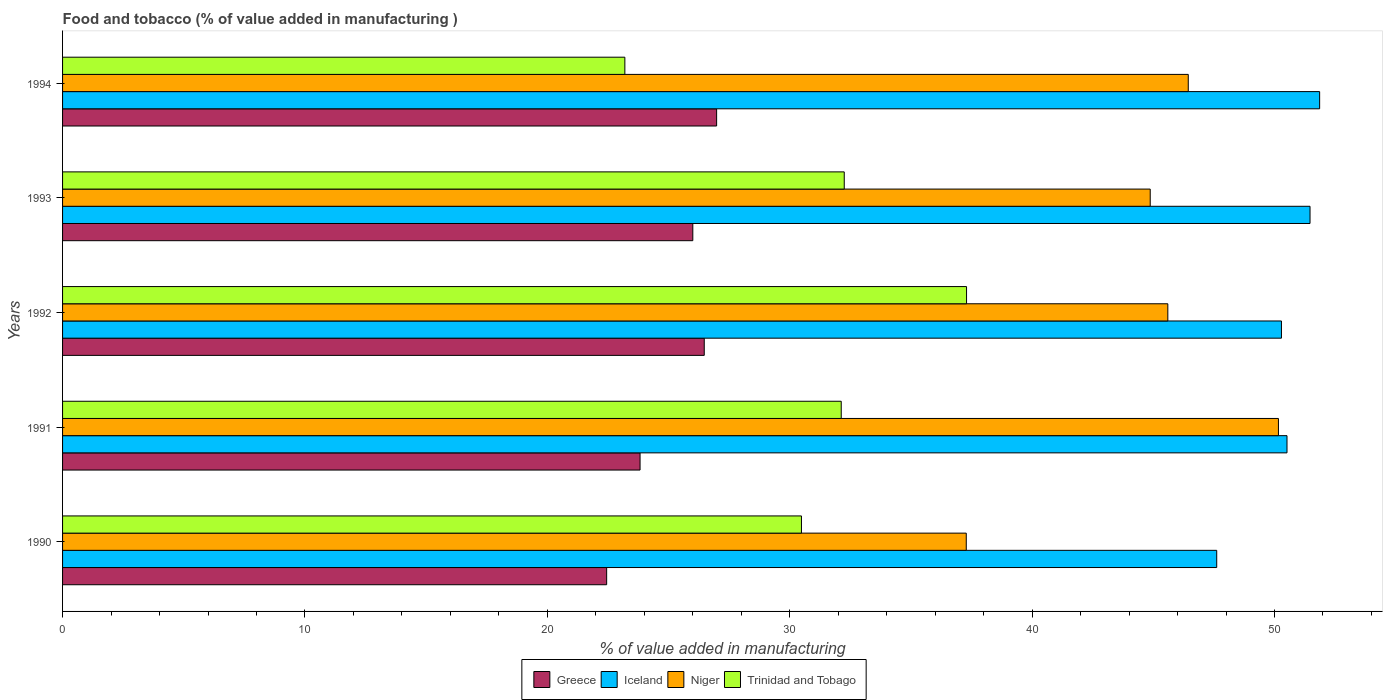How many different coloured bars are there?
Offer a very short reply. 4. What is the label of the 1st group of bars from the top?
Ensure brevity in your answer.  1994. In how many cases, is the number of bars for a given year not equal to the number of legend labels?
Offer a terse response. 0. What is the value added in manufacturing food and tobacco in Trinidad and Tobago in 1992?
Keep it short and to the point. 37.3. Across all years, what is the maximum value added in manufacturing food and tobacco in Greece?
Make the answer very short. 26.98. Across all years, what is the minimum value added in manufacturing food and tobacco in Iceland?
Provide a short and direct response. 47.62. In which year was the value added in manufacturing food and tobacco in Greece minimum?
Give a very brief answer. 1990. What is the total value added in manufacturing food and tobacco in Niger in the graph?
Offer a terse response. 224.36. What is the difference between the value added in manufacturing food and tobacco in Niger in 1990 and that in 1992?
Make the answer very short. -8.32. What is the difference between the value added in manufacturing food and tobacco in Trinidad and Tobago in 1990 and the value added in manufacturing food and tobacco in Greece in 1991?
Offer a very short reply. 6.66. What is the average value added in manufacturing food and tobacco in Trinidad and Tobago per year?
Your answer should be very brief. 31.07. In the year 1991, what is the difference between the value added in manufacturing food and tobacco in Trinidad and Tobago and value added in manufacturing food and tobacco in Niger?
Your answer should be very brief. -18.04. In how many years, is the value added in manufacturing food and tobacco in Trinidad and Tobago greater than 20 %?
Make the answer very short. 5. What is the ratio of the value added in manufacturing food and tobacco in Greece in 1991 to that in 1992?
Make the answer very short. 0.9. Is the difference between the value added in manufacturing food and tobacco in Trinidad and Tobago in 1990 and 1993 greater than the difference between the value added in manufacturing food and tobacco in Niger in 1990 and 1993?
Make the answer very short. Yes. What is the difference between the highest and the second highest value added in manufacturing food and tobacco in Iceland?
Offer a terse response. 0.4. What is the difference between the highest and the lowest value added in manufacturing food and tobacco in Niger?
Keep it short and to the point. 12.88. Is the sum of the value added in manufacturing food and tobacco in Niger in 1992 and 1994 greater than the maximum value added in manufacturing food and tobacco in Greece across all years?
Make the answer very short. Yes. Is it the case that in every year, the sum of the value added in manufacturing food and tobacco in Greece and value added in manufacturing food and tobacco in Iceland is greater than the sum of value added in manufacturing food and tobacco in Trinidad and Tobago and value added in manufacturing food and tobacco in Niger?
Your answer should be compact. No. What does the 2nd bar from the top in 1991 represents?
Give a very brief answer. Niger. How many bars are there?
Make the answer very short. 20. Are all the bars in the graph horizontal?
Keep it short and to the point. Yes. Does the graph contain any zero values?
Your answer should be very brief. No. Does the graph contain grids?
Offer a terse response. No. How many legend labels are there?
Ensure brevity in your answer.  4. What is the title of the graph?
Provide a short and direct response. Food and tobacco (% of value added in manufacturing ). Does "Finland" appear as one of the legend labels in the graph?
Give a very brief answer. No. What is the label or title of the X-axis?
Give a very brief answer. % of value added in manufacturing. What is the % of value added in manufacturing of Greece in 1990?
Provide a succinct answer. 22.45. What is the % of value added in manufacturing of Iceland in 1990?
Ensure brevity in your answer.  47.62. What is the % of value added in manufacturing of Niger in 1990?
Give a very brief answer. 37.28. What is the % of value added in manufacturing in Trinidad and Tobago in 1990?
Your answer should be compact. 30.48. What is the % of value added in manufacturing in Greece in 1991?
Provide a short and direct response. 23.83. What is the % of value added in manufacturing in Iceland in 1991?
Make the answer very short. 50.52. What is the % of value added in manufacturing of Niger in 1991?
Offer a very short reply. 50.16. What is the % of value added in manufacturing of Trinidad and Tobago in 1991?
Offer a terse response. 32.13. What is the % of value added in manufacturing in Greece in 1992?
Your response must be concise. 26.47. What is the % of value added in manufacturing of Iceland in 1992?
Make the answer very short. 50.29. What is the % of value added in manufacturing of Niger in 1992?
Provide a succinct answer. 45.6. What is the % of value added in manufacturing of Trinidad and Tobago in 1992?
Offer a very short reply. 37.3. What is the % of value added in manufacturing of Greece in 1993?
Make the answer very short. 26. What is the % of value added in manufacturing of Iceland in 1993?
Provide a short and direct response. 51.47. What is the % of value added in manufacturing in Niger in 1993?
Your response must be concise. 44.87. What is the % of value added in manufacturing in Trinidad and Tobago in 1993?
Provide a succinct answer. 32.25. What is the % of value added in manufacturing in Greece in 1994?
Ensure brevity in your answer.  26.98. What is the % of value added in manufacturing in Iceland in 1994?
Ensure brevity in your answer.  51.86. What is the % of value added in manufacturing in Niger in 1994?
Keep it short and to the point. 46.44. What is the % of value added in manufacturing in Trinidad and Tobago in 1994?
Provide a short and direct response. 23.2. Across all years, what is the maximum % of value added in manufacturing of Greece?
Ensure brevity in your answer.  26.98. Across all years, what is the maximum % of value added in manufacturing in Iceland?
Offer a very short reply. 51.86. Across all years, what is the maximum % of value added in manufacturing of Niger?
Your response must be concise. 50.16. Across all years, what is the maximum % of value added in manufacturing in Trinidad and Tobago?
Your answer should be very brief. 37.3. Across all years, what is the minimum % of value added in manufacturing of Greece?
Ensure brevity in your answer.  22.45. Across all years, what is the minimum % of value added in manufacturing in Iceland?
Offer a very short reply. 47.62. Across all years, what is the minimum % of value added in manufacturing of Niger?
Your response must be concise. 37.28. Across all years, what is the minimum % of value added in manufacturing of Trinidad and Tobago?
Your answer should be compact. 23.2. What is the total % of value added in manufacturing in Greece in the graph?
Give a very brief answer. 125.73. What is the total % of value added in manufacturing of Iceland in the graph?
Keep it short and to the point. 251.75. What is the total % of value added in manufacturing of Niger in the graph?
Make the answer very short. 224.36. What is the total % of value added in manufacturing of Trinidad and Tobago in the graph?
Provide a short and direct response. 155.35. What is the difference between the % of value added in manufacturing of Greece in 1990 and that in 1991?
Your answer should be very brief. -1.38. What is the difference between the % of value added in manufacturing of Iceland in 1990 and that in 1991?
Give a very brief answer. -2.9. What is the difference between the % of value added in manufacturing in Niger in 1990 and that in 1991?
Your answer should be compact. -12.88. What is the difference between the % of value added in manufacturing in Trinidad and Tobago in 1990 and that in 1991?
Provide a succinct answer. -1.64. What is the difference between the % of value added in manufacturing in Greece in 1990 and that in 1992?
Give a very brief answer. -4.03. What is the difference between the % of value added in manufacturing of Iceland in 1990 and that in 1992?
Give a very brief answer. -2.67. What is the difference between the % of value added in manufacturing in Niger in 1990 and that in 1992?
Your answer should be compact. -8.32. What is the difference between the % of value added in manufacturing of Trinidad and Tobago in 1990 and that in 1992?
Provide a succinct answer. -6.81. What is the difference between the % of value added in manufacturing in Greece in 1990 and that in 1993?
Offer a very short reply. -3.55. What is the difference between the % of value added in manufacturing in Iceland in 1990 and that in 1993?
Make the answer very short. -3.85. What is the difference between the % of value added in manufacturing in Niger in 1990 and that in 1993?
Keep it short and to the point. -7.59. What is the difference between the % of value added in manufacturing in Trinidad and Tobago in 1990 and that in 1993?
Ensure brevity in your answer.  -1.77. What is the difference between the % of value added in manufacturing in Greece in 1990 and that in 1994?
Keep it short and to the point. -4.54. What is the difference between the % of value added in manufacturing of Iceland in 1990 and that in 1994?
Your answer should be compact. -4.25. What is the difference between the % of value added in manufacturing in Niger in 1990 and that in 1994?
Keep it short and to the point. -9.16. What is the difference between the % of value added in manufacturing of Trinidad and Tobago in 1990 and that in 1994?
Provide a succinct answer. 7.29. What is the difference between the % of value added in manufacturing in Greece in 1991 and that in 1992?
Keep it short and to the point. -2.65. What is the difference between the % of value added in manufacturing in Iceland in 1991 and that in 1992?
Keep it short and to the point. 0.23. What is the difference between the % of value added in manufacturing in Niger in 1991 and that in 1992?
Your answer should be very brief. 4.56. What is the difference between the % of value added in manufacturing in Trinidad and Tobago in 1991 and that in 1992?
Offer a terse response. -5.17. What is the difference between the % of value added in manufacturing in Greece in 1991 and that in 1993?
Your response must be concise. -2.18. What is the difference between the % of value added in manufacturing in Iceland in 1991 and that in 1993?
Offer a terse response. -0.95. What is the difference between the % of value added in manufacturing in Niger in 1991 and that in 1993?
Your answer should be very brief. 5.29. What is the difference between the % of value added in manufacturing in Trinidad and Tobago in 1991 and that in 1993?
Your answer should be very brief. -0.12. What is the difference between the % of value added in manufacturing in Greece in 1991 and that in 1994?
Give a very brief answer. -3.16. What is the difference between the % of value added in manufacturing in Iceland in 1991 and that in 1994?
Your response must be concise. -1.35. What is the difference between the % of value added in manufacturing in Niger in 1991 and that in 1994?
Your answer should be very brief. 3.72. What is the difference between the % of value added in manufacturing in Trinidad and Tobago in 1991 and that in 1994?
Provide a succinct answer. 8.93. What is the difference between the % of value added in manufacturing in Greece in 1992 and that in 1993?
Ensure brevity in your answer.  0.47. What is the difference between the % of value added in manufacturing of Iceland in 1992 and that in 1993?
Offer a very short reply. -1.18. What is the difference between the % of value added in manufacturing in Niger in 1992 and that in 1993?
Offer a terse response. 0.73. What is the difference between the % of value added in manufacturing in Trinidad and Tobago in 1992 and that in 1993?
Provide a short and direct response. 5.05. What is the difference between the % of value added in manufacturing of Greece in 1992 and that in 1994?
Keep it short and to the point. -0.51. What is the difference between the % of value added in manufacturing of Iceland in 1992 and that in 1994?
Give a very brief answer. -1.58. What is the difference between the % of value added in manufacturing in Niger in 1992 and that in 1994?
Make the answer very short. -0.84. What is the difference between the % of value added in manufacturing in Trinidad and Tobago in 1992 and that in 1994?
Offer a terse response. 14.1. What is the difference between the % of value added in manufacturing in Greece in 1993 and that in 1994?
Make the answer very short. -0.98. What is the difference between the % of value added in manufacturing of Iceland in 1993 and that in 1994?
Your answer should be very brief. -0.4. What is the difference between the % of value added in manufacturing in Niger in 1993 and that in 1994?
Your answer should be compact. -1.57. What is the difference between the % of value added in manufacturing in Trinidad and Tobago in 1993 and that in 1994?
Ensure brevity in your answer.  9.05. What is the difference between the % of value added in manufacturing of Greece in 1990 and the % of value added in manufacturing of Iceland in 1991?
Offer a very short reply. -28.07. What is the difference between the % of value added in manufacturing of Greece in 1990 and the % of value added in manufacturing of Niger in 1991?
Ensure brevity in your answer.  -27.72. What is the difference between the % of value added in manufacturing of Greece in 1990 and the % of value added in manufacturing of Trinidad and Tobago in 1991?
Your answer should be very brief. -9.68. What is the difference between the % of value added in manufacturing in Iceland in 1990 and the % of value added in manufacturing in Niger in 1991?
Your answer should be very brief. -2.55. What is the difference between the % of value added in manufacturing of Iceland in 1990 and the % of value added in manufacturing of Trinidad and Tobago in 1991?
Your answer should be very brief. 15.49. What is the difference between the % of value added in manufacturing of Niger in 1990 and the % of value added in manufacturing of Trinidad and Tobago in 1991?
Keep it short and to the point. 5.16. What is the difference between the % of value added in manufacturing in Greece in 1990 and the % of value added in manufacturing in Iceland in 1992?
Offer a very short reply. -27.84. What is the difference between the % of value added in manufacturing in Greece in 1990 and the % of value added in manufacturing in Niger in 1992?
Keep it short and to the point. -23.15. What is the difference between the % of value added in manufacturing of Greece in 1990 and the % of value added in manufacturing of Trinidad and Tobago in 1992?
Provide a succinct answer. -14.85. What is the difference between the % of value added in manufacturing in Iceland in 1990 and the % of value added in manufacturing in Niger in 1992?
Your answer should be compact. 2.02. What is the difference between the % of value added in manufacturing of Iceland in 1990 and the % of value added in manufacturing of Trinidad and Tobago in 1992?
Keep it short and to the point. 10.32. What is the difference between the % of value added in manufacturing of Niger in 1990 and the % of value added in manufacturing of Trinidad and Tobago in 1992?
Give a very brief answer. -0.01. What is the difference between the % of value added in manufacturing in Greece in 1990 and the % of value added in manufacturing in Iceland in 1993?
Your answer should be very brief. -29.02. What is the difference between the % of value added in manufacturing of Greece in 1990 and the % of value added in manufacturing of Niger in 1993?
Your response must be concise. -22.43. What is the difference between the % of value added in manufacturing of Greece in 1990 and the % of value added in manufacturing of Trinidad and Tobago in 1993?
Your response must be concise. -9.8. What is the difference between the % of value added in manufacturing of Iceland in 1990 and the % of value added in manufacturing of Niger in 1993?
Your response must be concise. 2.74. What is the difference between the % of value added in manufacturing of Iceland in 1990 and the % of value added in manufacturing of Trinidad and Tobago in 1993?
Your answer should be compact. 15.37. What is the difference between the % of value added in manufacturing in Niger in 1990 and the % of value added in manufacturing in Trinidad and Tobago in 1993?
Provide a short and direct response. 5.03. What is the difference between the % of value added in manufacturing in Greece in 1990 and the % of value added in manufacturing in Iceland in 1994?
Your answer should be very brief. -29.42. What is the difference between the % of value added in manufacturing in Greece in 1990 and the % of value added in manufacturing in Niger in 1994?
Make the answer very short. -24. What is the difference between the % of value added in manufacturing in Greece in 1990 and the % of value added in manufacturing in Trinidad and Tobago in 1994?
Offer a terse response. -0.75. What is the difference between the % of value added in manufacturing in Iceland in 1990 and the % of value added in manufacturing in Niger in 1994?
Your answer should be very brief. 1.17. What is the difference between the % of value added in manufacturing in Iceland in 1990 and the % of value added in manufacturing in Trinidad and Tobago in 1994?
Give a very brief answer. 24.42. What is the difference between the % of value added in manufacturing in Niger in 1990 and the % of value added in manufacturing in Trinidad and Tobago in 1994?
Offer a terse response. 14.09. What is the difference between the % of value added in manufacturing in Greece in 1991 and the % of value added in manufacturing in Iceland in 1992?
Provide a short and direct response. -26.46. What is the difference between the % of value added in manufacturing in Greece in 1991 and the % of value added in manufacturing in Niger in 1992?
Keep it short and to the point. -21.77. What is the difference between the % of value added in manufacturing of Greece in 1991 and the % of value added in manufacturing of Trinidad and Tobago in 1992?
Ensure brevity in your answer.  -13.47. What is the difference between the % of value added in manufacturing of Iceland in 1991 and the % of value added in manufacturing of Niger in 1992?
Provide a short and direct response. 4.92. What is the difference between the % of value added in manufacturing of Iceland in 1991 and the % of value added in manufacturing of Trinidad and Tobago in 1992?
Provide a succinct answer. 13.22. What is the difference between the % of value added in manufacturing in Niger in 1991 and the % of value added in manufacturing in Trinidad and Tobago in 1992?
Provide a short and direct response. 12.87. What is the difference between the % of value added in manufacturing in Greece in 1991 and the % of value added in manufacturing in Iceland in 1993?
Make the answer very short. -27.64. What is the difference between the % of value added in manufacturing of Greece in 1991 and the % of value added in manufacturing of Niger in 1993?
Provide a succinct answer. -21.05. What is the difference between the % of value added in manufacturing of Greece in 1991 and the % of value added in manufacturing of Trinidad and Tobago in 1993?
Your response must be concise. -8.42. What is the difference between the % of value added in manufacturing in Iceland in 1991 and the % of value added in manufacturing in Niger in 1993?
Provide a short and direct response. 5.64. What is the difference between the % of value added in manufacturing in Iceland in 1991 and the % of value added in manufacturing in Trinidad and Tobago in 1993?
Keep it short and to the point. 18.27. What is the difference between the % of value added in manufacturing in Niger in 1991 and the % of value added in manufacturing in Trinidad and Tobago in 1993?
Make the answer very short. 17.91. What is the difference between the % of value added in manufacturing in Greece in 1991 and the % of value added in manufacturing in Iceland in 1994?
Provide a succinct answer. -28.04. What is the difference between the % of value added in manufacturing in Greece in 1991 and the % of value added in manufacturing in Niger in 1994?
Give a very brief answer. -22.62. What is the difference between the % of value added in manufacturing in Greece in 1991 and the % of value added in manufacturing in Trinidad and Tobago in 1994?
Ensure brevity in your answer.  0.63. What is the difference between the % of value added in manufacturing of Iceland in 1991 and the % of value added in manufacturing of Niger in 1994?
Offer a very short reply. 4.07. What is the difference between the % of value added in manufacturing of Iceland in 1991 and the % of value added in manufacturing of Trinidad and Tobago in 1994?
Your answer should be very brief. 27.32. What is the difference between the % of value added in manufacturing of Niger in 1991 and the % of value added in manufacturing of Trinidad and Tobago in 1994?
Your answer should be compact. 26.96. What is the difference between the % of value added in manufacturing in Greece in 1992 and the % of value added in manufacturing in Iceland in 1993?
Provide a succinct answer. -24.99. What is the difference between the % of value added in manufacturing in Greece in 1992 and the % of value added in manufacturing in Niger in 1993?
Keep it short and to the point. -18.4. What is the difference between the % of value added in manufacturing in Greece in 1992 and the % of value added in manufacturing in Trinidad and Tobago in 1993?
Offer a terse response. -5.78. What is the difference between the % of value added in manufacturing in Iceland in 1992 and the % of value added in manufacturing in Niger in 1993?
Provide a succinct answer. 5.41. What is the difference between the % of value added in manufacturing in Iceland in 1992 and the % of value added in manufacturing in Trinidad and Tobago in 1993?
Make the answer very short. 18.04. What is the difference between the % of value added in manufacturing in Niger in 1992 and the % of value added in manufacturing in Trinidad and Tobago in 1993?
Your response must be concise. 13.35. What is the difference between the % of value added in manufacturing of Greece in 1992 and the % of value added in manufacturing of Iceland in 1994?
Your answer should be very brief. -25.39. What is the difference between the % of value added in manufacturing of Greece in 1992 and the % of value added in manufacturing of Niger in 1994?
Your answer should be compact. -19.97. What is the difference between the % of value added in manufacturing in Greece in 1992 and the % of value added in manufacturing in Trinidad and Tobago in 1994?
Give a very brief answer. 3.28. What is the difference between the % of value added in manufacturing in Iceland in 1992 and the % of value added in manufacturing in Niger in 1994?
Offer a very short reply. 3.84. What is the difference between the % of value added in manufacturing in Iceland in 1992 and the % of value added in manufacturing in Trinidad and Tobago in 1994?
Your answer should be compact. 27.09. What is the difference between the % of value added in manufacturing of Niger in 1992 and the % of value added in manufacturing of Trinidad and Tobago in 1994?
Provide a succinct answer. 22.4. What is the difference between the % of value added in manufacturing in Greece in 1993 and the % of value added in manufacturing in Iceland in 1994?
Make the answer very short. -25.86. What is the difference between the % of value added in manufacturing in Greece in 1993 and the % of value added in manufacturing in Niger in 1994?
Your response must be concise. -20.44. What is the difference between the % of value added in manufacturing of Greece in 1993 and the % of value added in manufacturing of Trinidad and Tobago in 1994?
Ensure brevity in your answer.  2.8. What is the difference between the % of value added in manufacturing in Iceland in 1993 and the % of value added in manufacturing in Niger in 1994?
Offer a very short reply. 5.02. What is the difference between the % of value added in manufacturing of Iceland in 1993 and the % of value added in manufacturing of Trinidad and Tobago in 1994?
Ensure brevity in your answer.  28.27. What is the difference between the % of value added in manufacturing in Niger in 1993 and the % of value added in manufacturing in Trinidad and Tobago in 1994?
Keep it short and to the point. 21.67. What is the average % of value added in manufacturing of Greece per year?
Your answer should be very brief. 25.15. What is the average % of value added in manufacturing of Iceland per year?
Your answer should be very brief. 50.35. What is the average % of value added in manufacturing of Niger per year?
Your response must be concise. 44.87. What is the average % of value added in manufacturing of Trinidad and Tobago per year?
Ensure brevity in your answer.  31.07. In the year 1990, what is the difference between the % of value added in manufacturing of Greece and % of value added in manufacturing of Iceland?
Give a very brief answer. -25.17. In the year 1990, what is the difference between the % of value added in manufacturing of Greece and % of value added in manufacturing of Niger?
Offer a terse response. -14.84. In the year 1990, what is the difference between the % of value added in manufacturing in Greece and % of value added in manufacturing in Trinidad and Tobago?
Keep it short and to the point. -8.04. In the year 1990, what is the difference between the % of value added in manufacturing in Iceland and % of value added in manufacturing in Niger?
Your answer should be very brief. 10.33. In the year 1990, what is the difference between the % of value added in manufacturing of Iceland and % of value added in manufacturing of Trinidad and Tobago?
Keep it short and to the point. 17.13. In the year 1990, what is the difference between the % of value added in manufacturing of Niger and % of value added in manufacturing of Trinidad and Tobago?
Your answer should be compact. 6.8. In the year 1991, what is the difference between the % of value added in manufacturing of Greece and % of value added in manufacturing of Iceland?
Offer a very short reply. -26.69. In the year 1991, what is the difference between the % of value added in manufacturing of Greece and % of value added in manufacturing of Niger?
Your answer should be compact. -26.34. In the year 1991, what is the difference between the % of value added in manufacturing of Greece and % of value added in manufacturing of Trinidad and Tobago?
Provide a succinct answer. -8.3. In the year 1991, what is the difference between the % of value added in manufacturing in Iceland and % of value added in manufacturing in Niger?
Offer a very short reply. 0.35. In the year 1991, what is the difference between the % of value added in manufacturing in Iceland and % of value added in manufacturing in Trinidad and Tobago?
Keep it short and to the point. 18.39. In the year 1991, what is the difference between the % of value added in manufacturing of Niger and % of value added in manufacturing of Trinidad and Tobago?
Your answer should be compact. 18.04. In the year 1992, what is the difference between the % of value added in manufacturing of Greece and % of value added in manufacturing of Iceland?
Ensure brevity in your answer.  -23.81. In the year 1992, what is the difference between the % of value added in manufacturing in Greece and % of value added in manufacturing in Niger?
Keep it short and to the point. -19.13. In the year 1992, what is the difference between the % of value added in manufacturing in Greece and % of value added in manufacturing in Trinidad and Tobago?
Your response must be concise. -10.82. In the year 1992, what is the difference between the % of value added in manufacturing of Iceland and % of value added in manufacturing of Niger?
Provide a short and direct response. 4.69. In the year 1992, what is the difference between the % of value added in manufacturing of Iceland and % of value added in manufacturing of Trinidad and Tobago?
Your response must be concise. 12.99. In the year 1992, what is the difference between the % of value added in manufacturing of Niger and % of value added in manufacturing of Trinidad and Tobago?
Your answer should be compact. 8.3. In the year 1993, what is the difference between the % of value added in manufacturing in Greece and % of value added in manufacturing in Iceland?
Provide a short and direct response. -25.46. In the year 1993, what is the difference between the % of value added in manufacturing in Greece and % of value added in manufacturing in Niger?
Give a very brief answer. -18.87. In the year 1993, what is the difference between the % of value added in manufacturing in Greece and % of value added in manufacturing in Trinidad and Tobago?
Your response must be concise. -6.25. In the year 1993, what is the difference between the % of value added in manufacturing in Iceland and % of value added in manufacturing in Niger?
Provide a short and direct response. 6.59. In the year 1993, what is the difference between the % of value added in manufacturing of Iceland and % of value added in manufacturing of Trinidad and Tobago?
Offer a very short reply. 19.22. In the year 1993, what is the difference between the % of value added in manufacturing of Niger and % of value added in manufacturing of Trinidad and Tobago?
Keep it short and to the point. 12.62. In the year 1994, what is the difference between the % of value added in manufacturing of Greece and % of value added in manufacturing of Iceland?
Ensure brevity in your answer.  -24.88. In the year 1994, what is the difference between the % of value added in manufacturing of Greece and % of value added in manufacturing of Niger?
Provide a succinct answer. -19.46. In the year 1994, what is the difference between the % of value added in manufacturing in Greece and % of value added in manufacturing in Trinidad and Tobago?
Give a very brief answer. 3.79. In the year 1994, what is the difference between the % of value added in manufacturing in Iceland and % of value added in manufacturing in Niger?
Give a very brief answer. 5.42. In the year 1994, what is the difference between the % of value added in manufacturing in Iceland and % of value added in manufacturing in Trinidad and Tobago?
Provide a succinct answer. 28.66. In the year 1994, what is the difference between the % of value added in manufacturing in Niger and % of value added in manufacturing in Trinidad and Tobago?
Give a very brief answer. 23.24. What is the ratio of the % of value added in manufacturing in Greece in 1990 to that in 1991?
Provide a succinct answer. 0.94. What is the ratio of the % of value added in manufacturing of Iceland in 1990 to that in 1991?
Provide a succinct answer. 0.94. What is the ratio of the % of value added in manufacturing of Niger in 1990 to that in 1991?
Your answer should be compact. 0.74. What is the ratio of the % of value added in manufacturing of Trinidad and Tobago in 1990 to that in 1991?
Offer a very short reply. 0.95. What is the ratio of the % of value added in manufacturing of Greece in 1990 to that in 1992?
Ensure brevity in your answer.  0.85. What is the ratio of the % of value added in manufacturing of Iceland in 1990 to that in 1992?
Keep it short and to the point. 0.95. What is the ratio of the % of value added in manufacturing in Niger in 1990 to that in 1992?
Your response must be concise. 0.82. What is the ratio of the % of value added in manufacturing of Trinidad and Tobago in 1990 to that in 1992?
Offer a terse response. 0.82. What is the ratio of the % of value added in manufacturing in Greece in 1990 to that in 1993?
Provide a short and direct response. 0.86. What is the ratio of the % of value added in manufacturing of Iceland in 1990 to that in 1993?
Provide a short and direct response. 0.93. What is the ratio of the % of value added in manufacturing of Niger in 1990 to that in 1993?
Keep it short and to the point. 0.83. What is the ratio of the % of value added in manufacturing of Trinidad and Tobago in 1990 to that in 1993?
Provide a succinct answer. 0.95. What is the ratio of the % of value added in manufacturing in Greece in 1990 to that in 1994?
Provide a succinct answer. 0.83. What is the ratio of the % of value added in manufacturing of Iceland in 1990 to that in 1994?
Ensure brevity in your answer.  0.92. What is the ratio of the % of value added in manufacturing of Niger in 1990 to that in 1994?
Your answer should be very brief. 0.8. What is the ratio of the % of value added in manufacturing in Trinidad and Tobago in 1990 to that in 1994?
Offer a very short reply. 1.31. What is the ratio of the % of value added in manufacturing in Iceland in 1991 to that in 1992?
Provide a succinct answer. 1. What is the ratio of the % of value added in manufacturing in Niger in 1991 to that in 1992?
Provide a succinct answer. 1.1. What is the ratio of the % of value added in manufacturing of Trinidad and Tobago in 1991 to that in 1992?
Your response must be concise. 0.86. What is the ratio of the % of value added in manufacturing in Greece in 1991 to that in 1993?
Offer a terse response. 0.92. What is the ratio of the % of value added in manufacturing in Iceland in 1991 to that in 1993?
Offer a very short reply. 0.98. What is the ratio of the % of value added in manufacturing of Niger in 1991 to that in 1993?
Your answer should be compact. 1.12. What is the ratio of the % of value added in manufacturing of Greece in 1991 to that in 1994?
Offer a terse response. 0.88. What is the ratio of the % of value added in manufacturing in Iceland in 1991 to that in 1994?
Your response must be concise. 0.97. What is the ratio of the % of value added in manufacturing in Niger in 1991 to that in 1994?
Offer a very short reply. 1.08. What is the ratio of the % of value added in manufacturing of Trinidad and Tobago in 1991 to that in 1994?
Provide a succinct answer. 1.38. What is the ratio of the % of value added in manufacturing of Greece in 1992 to that in 1993?
Your answer should be compact. 1.02. What is the ratio of the % of value added in manufacturing of Iceland in 1992 to that in 1993?
Make the answer very short. 0.98. What is the ratio of the % of value added in manufacturing of Niger in 1992 to that in 1993?
Provide a succinct answer. 1.02. What is the ratio of the % of value added in manufacturing of Trinidad and Tobago in 1992 to that in 1993?
Your answer should be very brief. 1.16. What is the ratio of the % of value added in manufacturing in Greece in 1992 to that in 1994?
Make the answer very short. 0.98. What is the ratio of the % of value added in manufacturing in Iceland in 1992 to that in 1994?
Offer a very short reply. 0.97. What is the ratio of the % of value added in manufacturing of Niger in 1992 to that in 1994?
Make the answer very short. 0.98. What is the ratio of the % of value added in manufacturing of Trinidad and Tobago in 1992 to that in 1994?
Make the answer very short. 1.61. What is the ratio of the % of value added in manufacturing in Greece in 1993 to that in 1994?
Offer a very short reply. 0.96. What is the ratio of the % of value added in manufacturing in Iceland in 1993 to that in 1994?
Ensure brevity in your answer.  0.99. What is the ratio of the % of value added in manufacturing in Niger in 1993 to that in 1994?
Keep it short and to the point. 0.97. What is the ratio of the % of value added in manufacturing of Trinidad and Tobago in 1993 to that in 1994?
Your response must be concise. 1.39. What is the difference between the highest and the second highest % of value added in manufacturing of Greece?
Keep it short and to the point. 0.51. What is the difference between the highest and the second highest % of value added in manufacturing of Iceland?
Your answer should be compact. 0.4. What is the difference between the highest and the second highest % of value added in manufacturing of Niger?
Provide a succinct answer. 3.72. What is the difference between the highest and the second highest % of value added in manufacturing in Trinidad and Tobago?
Offer a terse response. 5.05. What is the difference between the highest and the lowest % of value added in manufacturing of Greece?
Your answer should be compact. 4.54. What is the difference between the highest and the lowest % of value added in manufacturing in Iceland?
Give a very brief answer. 4.25. What is the difference between the highest and the lowest % of value added in manufacturing of Niger?
Your answer should be very brief. 12.88. What is the difference between the highest and the lowest % of value added in manufacturing in Trinidad and Tobago?
Give a very brief answer. 14.1. 